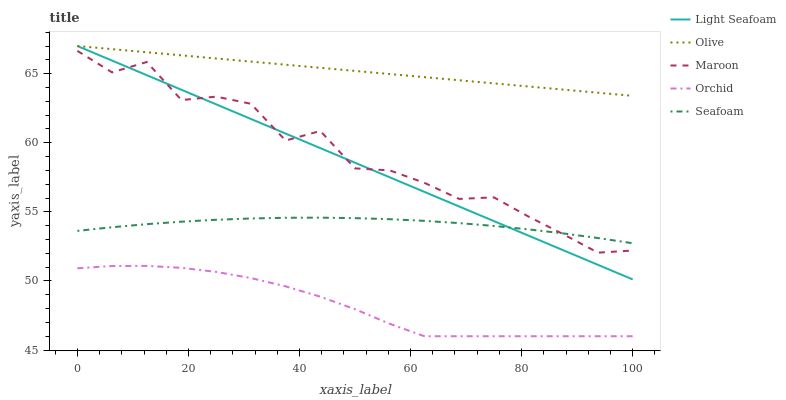Does Orchid have the minimum area under the curve?
Answer yes or no. Yes. Does Olive have the maximum area under the curve?
Answer yes or no. Yes. Does Light Seafoam have the minimum area under the curve?
Answer yes or no. No. Does Light Seafoam have the maximum area under the curve?
Answer yes or no. No. Is Olive the smoothest?
Answer yes or no. Yes. Is Maroon the roughest?
Answer yes or no. Yes. Is Light Seafoam the smoothest?
Answer yes or no. No. Is Light Seafoam the roughest?
Answer yes or no. No. Does Light Seafoam have the lowest value?
Answer yes or no. No. Does Light Seafoam have the highest value?
Answer yes or no. Yes. Does Seafoam have the highest value?
Answer yes or no. No. Is Maroon less than Olive?
Answer yes or no. Yes. Is Maroon greater than Orchid?
Answer yes or no. Yes. Does Maroon intersect Olive?
Answer yes or no. No. 